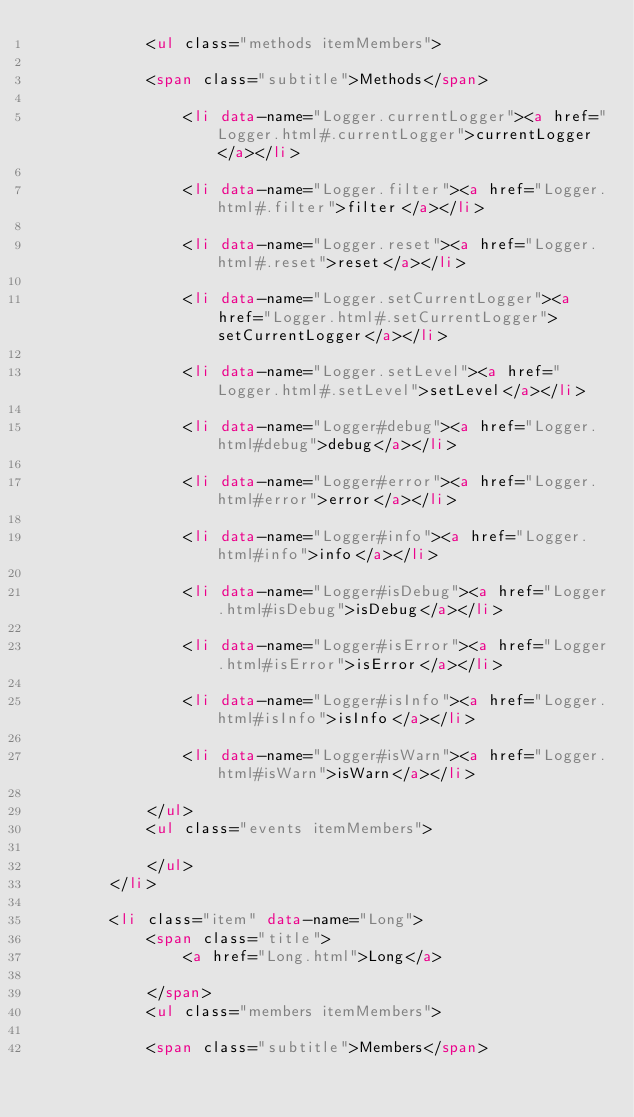Convert code to text. <code><loc_0><loc_0><loc_500><loc_500><_HTML_>            <ul class="methods itemMembers">
            
            <span class="subtitle">Methods</span>
            
                <li data-name="Logger.currentLogger"><a href="Logger.html#.currentLogger">currentLogger</a></li>
            
                <li data-name="Logger.filter"><a href="Logger.html#.filter">filter</a></li>
            
                <li data-name="Logger.reset"><a href="Logger.html#.reset">reset</a></li>
            
                <li data-name="Logger.setCurrentLogger"><a href="Logger.html#.setCurrentLogger">setCurrentLogger</a></li>
            
                <li data-name="Logger.setLevel"><a href="Logger.html#.setLevel">setLevel</a></li>
            
                <li data-name="Logger#debug"><a href="Logger.html#debug">debug</a></li>
            
                <li data-name="Logger#error"><a href="Logger.html#error">error</a></li>
            
                <li data-name="Logger#info"><a href="Logger.html#info">info</a></li>
            
                <li data-name="Logger#isDebug"><a href="Logger.html#isDebug">isDebug</a></li>
            
                <li data-name="Logger#isError"><a href="Logger.html#isError">isError</a></li>
            
                <li data-name="Logger#isInfo"><a href="Logger.html#isInfo">isInfo</a></li>
            
                <li data-name="Logger#isWarn"><a href="Logger.html#isWarn">isWarn</a></li>
            
            </ul>
            <ul class="events itemMembers">
            
            </ul>
        </li>
    
        <li class="item" data-name="Long">
            <span class="title">
                <a href="Long.html">Long</a>
                
            </span>
            <ul class="members itemMembers">
            
            <span class="subtitle">Members</span>
            </code> 